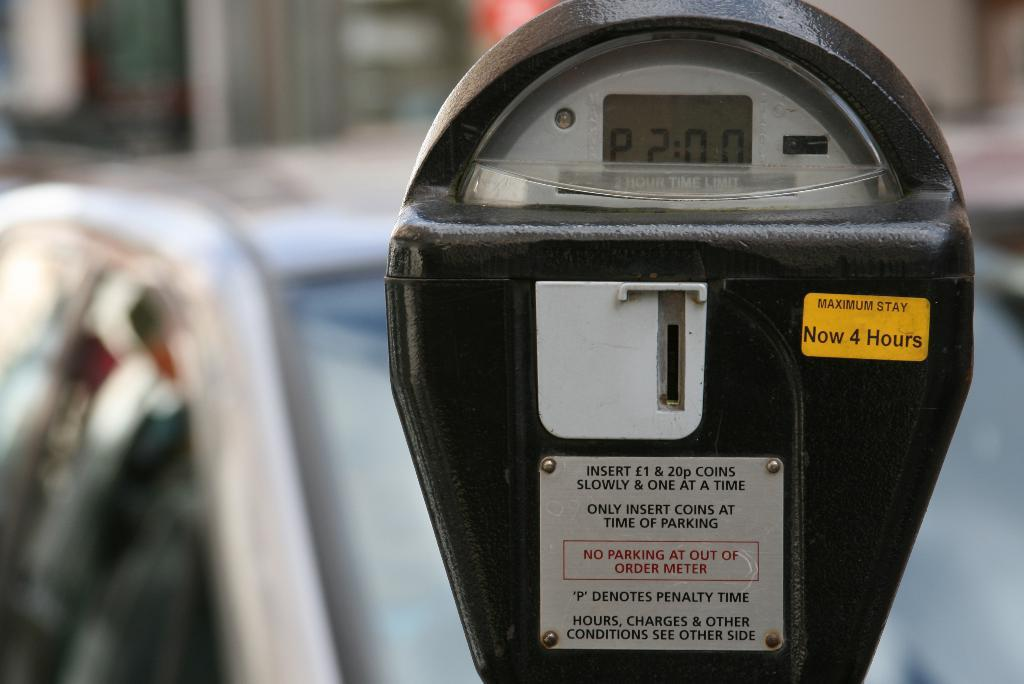<image>
Provide a brief description of the given image. a parking meter with about 2 hours left on the screen 